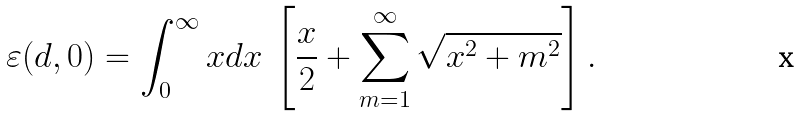Convert formula to latex. <formula><loc_0><loc_0><loc_500><loc_500>\varepsilon ( d , 0 ) = \int ^ { \infty } _ { 0 } x d x \ \left [ \frac { x } { 2 } + \sum _ { m = 1 } ^ { \infty } \sqrt { x ^ { 2 } + m ^ { 2 } } \right ] .</formula> 